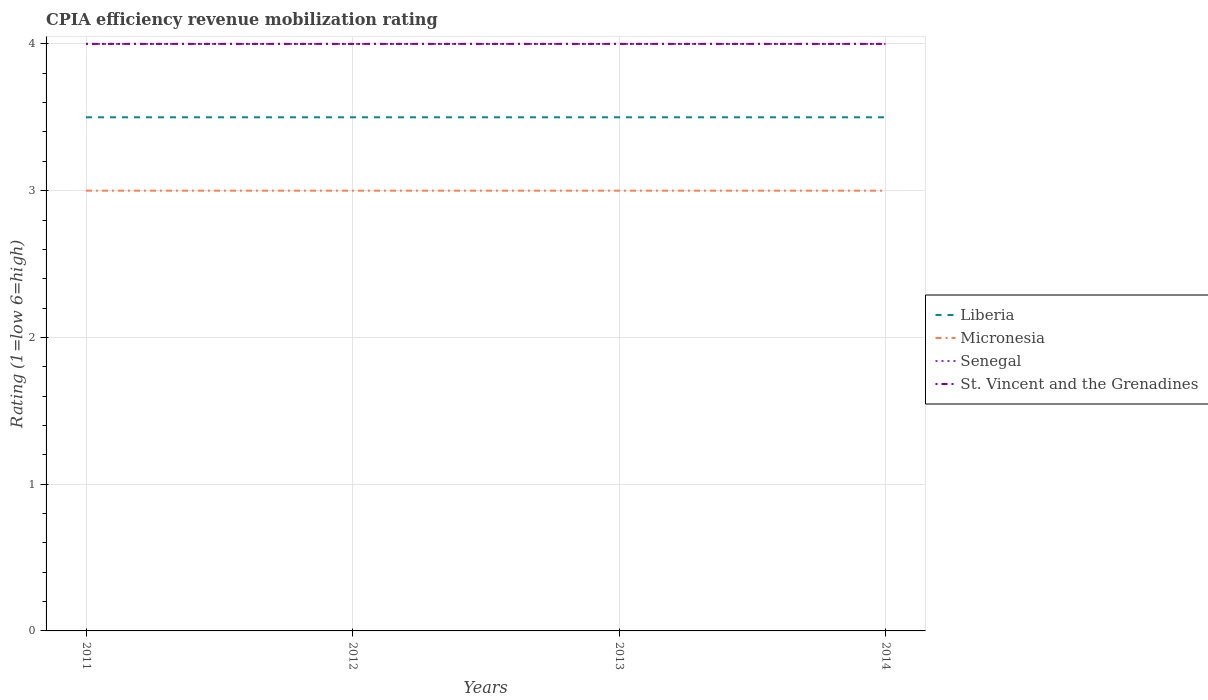Does the line corresponding to St. Vincent and the Grenadines intersect with the line corresponding to Senegal?
Your answer should be compact. Yes. Is the number of lines equal to the number of legend labels?
Make the answer very short. Yes. Across all years, what is the maximum CPIA rating in St. Vincent and the Grenadines?
Your answer should be compact. 4. In which year was the CPIA rating in Senegal maximum?
Your answer should be compact. 2011. What is the difference between the highest and the lowest CPIA rating in Liberia?
Give a very brief answer. 0. Is the CPIA rating in Senegal strictly greater than the CPIA rating in St. Vincent and the Grenadines over the years?
Offer a terse response. No. How many lines are there?
Keep it short and to the point. 4. Does the graph contain grids?
Give a very brief answer. Yes. What is the title of the graph?
Give a very brief answer. CPIA efficiency revenue mobilization rating. Does "Saudi Arabia" appear as one of the legend labels in the graph?
Provide a short and direct response. No. What is the label or title of the X-axis?
Offer a terse response. Years. What is the label or title of the Y-axis?
Provide a succinct answer. Rating (1=low 6=high). What is the Rating (1=low 6=high) in Micronesia in 2011?
Your answer should be very brief. 3. What is the Rating (1=low 6=high) in St. Vincent and the Grenadines in 2011?
Your answer should be very brief. 4. What is the Rating (1=low 6=high) of Liberia in 2012?
Give a very brief answer. 3.5. What is the Rating (1=low 6=high) of Micronesia in 2012?
Ensure brevity in your answer.  3. What is the Rating (1=low 6=high) of St. Vincent and the Grenadines in 2012?
Keep it short and to the point. 4. What is the Rating (1=low 6=high) in Liberia in 2013?
Keep it short and to the point. 3.5. What is the Rating (1=low 6=high) in Micronesia in 2013?
Give a very brief answer. 3. What is the Rating (1=low 6=high) in St. Vincent and the Grenadines in 2014?
Keep it short and to the point. 4. Across all years, what is the maximum Rating (1=low 6=high) in St. Vincent and the Grenadines?
Ensure brevity in your answer.  4. Across all years, what is the minimum Rating (1=low 6=high) in Senegal?
Give a very brief answer. 4. Across all years, what is the minimum Rating (1=low 6=high) in St. Vincent and the Grenadines?
Keep it short and to the point. 4. What is the total Rating (1=low 6=high) in Liberia in the graph?
Your answer should be compact. 14. What is the total Rating (1=low 6=high) in Micronesia in the graph?
Give a very brief answer. 12. What is the total Rating (1=low 6=high) of Senegal in the graph?
Make the answer very short. 16. What is the total Rating (1=low 6=high) in St. Vincent and the Grenadines in the graph?
Give a very brief answer. 16. What is the difference between the Rating (1=low 6=high) in Liberia in 2011 and that in 2012?
Your answer should be very brief. 0. What is the difference between the Rating (1=low 6=high) of Senegal in 2011 and that in 2012?
Offer a terse response. 0. What is the difference between the Rating (1=low 6=high) in Micronesia in 2011 and that in 2013?
Keep it short and to the point. 0. What is the difference between the Rating (1=low 6=high) of St. Vincent and the Grenadines in 2011 and that in 2013?
Provide a succinct answer. 0. What is the difference between the Rating (1=low 6=high) in Liberia in 2011 and that in 2014?
Provide a succinct answer. 0. What is the difference between the Rating (1=low 6=high) in Micronesia in 2011 and that in 2014?
Make the answer very short. 0. What is the difference between the Rating (1=low 6=high) in Senegal in 2011 and that in 2014?
Offer a very short reply. 0. What is the difference between the Rating (1=low 6=high) of Liberia in 2012 and that in 2013?
Provide a short and direct response. 0. What is the difference between the Rating (1=low 6=high) in Micronesia in 2012 and that in 2013?
Make the answer very short. 0. What is the difference between the Rating (1=low 6=high) of Senegal in 2012 and that in 2013?
Your answer should be compact. 0. What is the difference between the Rating (1=low 6=high) of Liberia in 2012 and that in 2014?
Ensure brevity in your answer.  0. What is the difference between the Rating (1=low 6=high) of St. Vincent and the Grenadines in 2012 and that in 2014?
Make the answer very short. 0. What is the difference between the Rating (1=low 6=high) of Liberia in 2013 and that in 2014?
Provide a short and direct response. 0. What is the difference between the Rating (1=low 6=high) in Micronesia in 2013 and that in 2014?
Keep it short and to the point. 0. What is the difference between the Rating (1=low 6=high) in Senegal in 2013 and that in 2014?
Ensure brevity in your answer.  0. What is the difference between the Rating (1=low 6=high) of St. Vincent and the Grenadines in 2013 and that in 2014?
Offer a terse response. 0. What is the difference between the Rating (1=low 6=high) in Liberia in 2011 and the Rating (1=low 6=high) in Micronesia in 2012?
Provide a succinct answer. 0.5. What is the difference between the Rating (1=low 6=high) in Liberia in 2011 and the Rating (1=low 6=high) in St. Vincent and the Grenadines in 2012?
Provide a succinct answer. -0.5. What is the difference between the Rating (1=low 6=high) of Senegal in 2011 and the Rating (1=low 6=high) of St. Vincent and the Grenadines in 2012?
Your answer should be compact. 0. What is the difference between the Rating (1=low 6=high) of Liberia in 2011 and the Rating (1=low 6=high) of Micronesia in 2013?
Provide a short and direct response. 0.5. What is the difference between the Rating (1=low 6=high) of Senegal in 2011 and the Rating (1=low 6=high) of St. Vincent and the Grenadines in 2013?
Provide a short and direct response. 0. What is the difference between the Rating (1=low 6=high) of Liberia in 2011 and the Rating (1=low 6=high) of Senegal in 2014?
Provide a short and direct response. -0.5. What is the difference between the Rating (1=low 6=high) in Liberia in 2011 and the Rating (1=low 6=high) in St. Vincent and the Grenadines in 2014?
Ensure brevity in your answer.  -0.5. What is the difference between the Rating (1=low 6=high) of Liberia in 2012 and the Rating (1=low 6=high) of Senegal in 2013?
Offer a very short reply. -0.5. What is the difference between the Rating (1=low 6=high) in Senegal in 2012 and the Rating (1=low 6=high) in St. Vincent and the Grenadines in 2013?
Provide a succinct answer. 0. What is the difference between the Rating (1=low 6=high) in Liberia in 2012 and the Rating (1=low 6=high) in Micronesia in 2014?
Offer a very short reply. 0.5. What is the difference between the Rating (1=low 6=high) in Micronesia in 2012 and the Rating (1=low 6=high) in Senegal in 2014?
Make the answer very short. -1. What is the difference between the Rating (1=low 6=high) in Micronesia in 2012 and the Rating (1=low 6=high) in St. Vincent and the Grenadines in 2014?
Offer a very short reply. -1. What is the difference between the Rating (1=low 6=high) of Senegal in 2012 and the Rating (1=low 6=high) of St. Vincent and the Grenadines in 2014?
Offer a very short reply. 0. What is the difference between the Rating (1=low 6=high) in Senegal in 2013 and the Rating (1=low 6=high) in St. Vincent and the Grenadines in 2014?
Your answer should be compact. 0. What is the average Rating (1=low 6=high) in Micronesia per year?
Keep it short and to the point. 3. What is the average Rating (1=low 6=high) in St. Vincent and the Grenadines per year?
Keep it short and to the point. 4. In the year 2011, what is the difference between the Rating (1=low 6=high) in Liberia and Rating (1=low 6=high) in Micronesia?
Provide a succinct answer. 0.5. In the year 2011, what is the difference between the Rating (1=low 6=high) of Liberia and Rating (1=low 6=high) of Senegal?
Give a very brief answer. -0.5. In the year 2011, what is the difference between the Rating (1=low 6=high) of Micronesia and Rating (1=low 6=high) of Senegal?
Ensure brevity in your answer.  -1. In the year 2012, what is the difference between the Rating (1=low 6=high) of Liberia and Rating (1=low 6=high) of Micronesia?
Offer a terse response. 0.5. In the year 2012, what is the difference between the Rating (1=low 6=high) of Liberia and Rating (1=low 6=high) of Senegal?
Give a very brief answer. -0.5. In the year 2012, what is the difference between the Rating (1=low 6=high) in Liberia and Rating (1=low 6=high) in St. Vincent and the Grenadines?
Your response must be concise. -0.5. In the year 2012, what is the difference between the Rating (1=low 6=high) of Micronesia and Rating (1=low 6=high) of Senegal?
Ensure brevity in your answer.  -1. In the year 2012, what is the difference between the Rating (1=low 6=high) of Micronesia and Rating (1=low 6=high) of St. Vincent and the Grenadines?
Your answer should be compact. -1. In the year 2013, what is the difference between the Rating (1=low 6=high) of Liberia and Rating (1=low 6=high) of Micronesia?
Provide a short and direct response. 0.5. In the year 2013, what is the difference between the Rating (1=low 6=high) of Liberia and Rating (1=low 6=high) of Senegal?
Provide a short and direct response. -0.5. In the year 2013, what is the difference between the Rating (1=low 6=high) of Liberia and Rating (1=low 6=high) of St. Vincent and the Grenadines?
Ensure brevity in your answer.  -0.5. In the year 2013, what is the difference between the Rating (1=low 6=high) in Micronesia and Rating (1=low 6=high) in Senegal?
Ensure brevity in your answer.  -1. In the year 2013, what is the difference between the Rating (1=low 6=high) of Micronesia and Rating (1=low 6=high) of St. Vincent and the Grenadines?
Ensure brevity in your answer.  -1. In the year 2014, what is the difference between the Rating (1=low 6=high) in Liberia and Rating (1=low 6=high) in Senegal?
Your answer should be very brief. -0.5. In the year 2014, what is the difference between the Rating (1=low 6=high) of Micronesia and Rating (1=low 6=high) of Senegal?
Ensure brevity in your answer.  -1. In the year 2014, what is the difference between the Rating (1=low 6=high) of Senegal and Rating (1=low 6=high) of St. Vincent and the Grenadines?
Your response must be concise. 0. What is the ratio of the Rating (1=low 6=high) in Liberia in 2011 to that in 2012?
Keep it short and to the point. 1. What is the ratio of the Rating (1=low 6=high) of St. Vincent and the Grenadines in 2011 to that in 2012?
Keep it short and to the point. 1. What is the ratio of the Rating (1=low 6=high) of Liberia in 2011 to that in 2013?
Make the answer very short. 1. What is the ratio of the Rating (1=low 6=high) of Senegal in 2011 to that in 2013?
Provide a succinct answer. 1. What is the ratio of the Rating (1=low 6=high) in St. Vincent and the Grenadines in 2011 to that in 2013?
Your answer should be very brief. 1. What is the ratio of the Rating (1=low 6=high) of Liberia in 2011 to that in 2014?
Keep it short and to the point. 1. What is the ratio of the Rating (1=low 6=high) of St. Vincent and the Grenadines in 2011 to that in 2014?
Offer a terse response. 1. What is the ratio of the Rating (1=low 6=high) of Liberia in 2012 to that in 2013?
Keep it short and to the point. 1. What is the ratio of the Rating (1=low 6=high) of Micronesia in 2012 to that in 2013?
Offer a very short reply. 1. What is the ratio of the Rating (1=low 6=high) of Senegal in 2012 to that in 2013?
Make the answer very short. 1. What is the ratio of the Rating (1=low 6=high) of Liberia in 2012 to that in 2014?
Give a very brief answer. 1. What is the ratio of the Rating (1=low 6=high) in Senegal in 2012 to that in 2014?
Give a very brief answer. 1. What is the ratio of the Rating (1=low 6=high) in Liberia in 2013 to that in 2014?
Provide a succinct answer. 1. What is the ratio of the Rating (1=low 6=high) of St. Vincent and the Grenadines in 2013 to that in 2014?
Offer a terse response. 1. What is the difference between the highest and the second highest Rating (1=low 6=high) in Senegal?
Keep it short and to the point. 0. What is the difference between the highest and the second highest Rating (1=low 6=high) of St. Vincent and the Grenadines?
Your answer should be compact. 0. What is the difference between the highest and the lowest Rating (1=low 6=high) in St. Vincent and the Grenadines?
Provide a short and direct response. 0. 